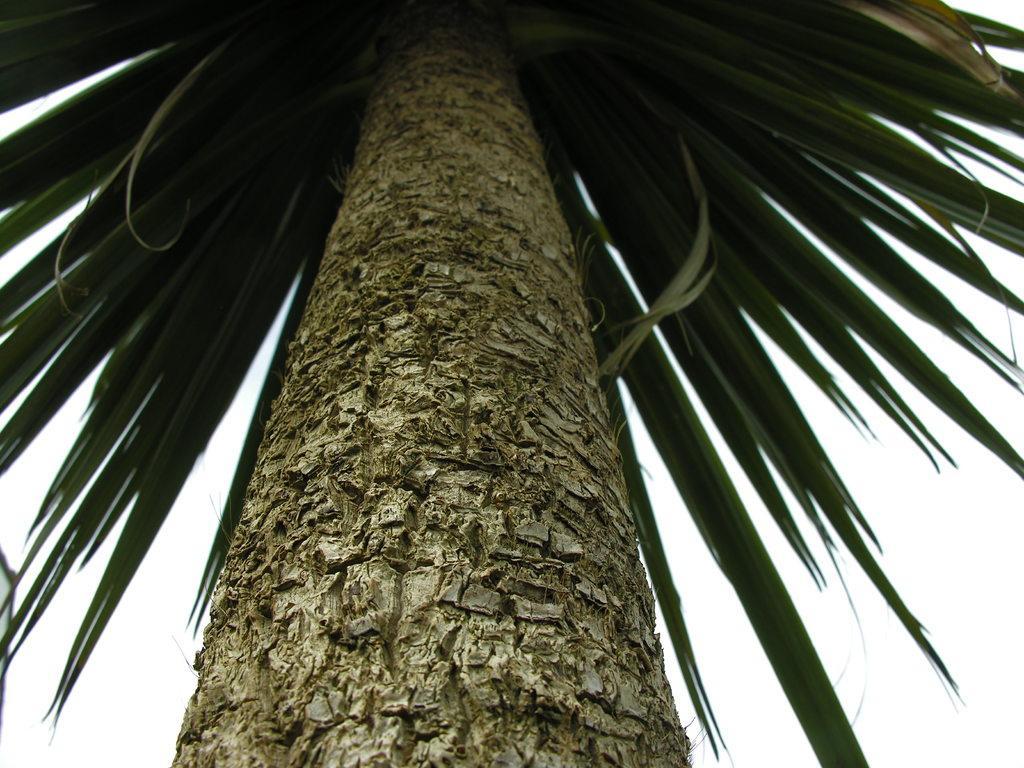Describe this image in one or two sentences. In the image in the center we can see one tree. In the background there is a sky and clouds. 